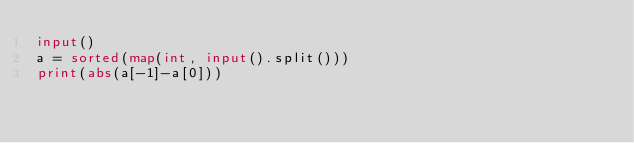Convert code to text. <code><loc_0><loc_0><loc_500><loc_500><_Python_>input()
a = sorted(map(int, input().split()))
print(abs(a[-1]-a[0]))</code> 